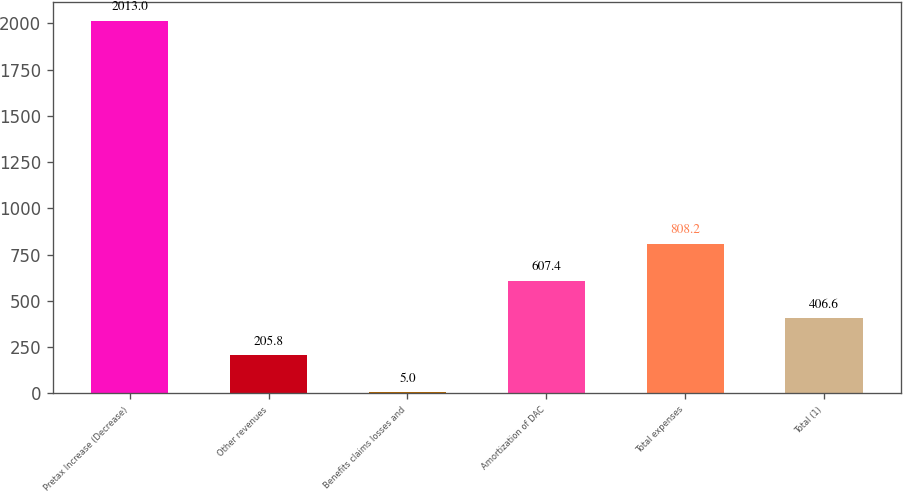Convert chart. <chart><loc_0><loc_0><loc_500><loc_500><bar_chart><fcel>Pretax Increase (Decrease)<fcel>Other revenues<fcel>Benefits claims losses and<fcel>Amortization of DAC<fcel>Total expenses<fcel>Total (1)<nl><fcel>2013<fcel>205.8<fcel>5<fcel>607.4<fcel>808.2<fcel>406.6<nl></chart> 